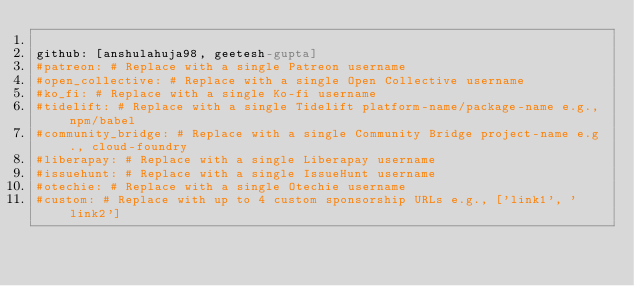<code> <loc_0><loc_0><loc_500><loc_500><_YAML_>
github: [anshulahuja98, geetesh-gupta]
#patreon: # Replace with a single Patreon username
#open_collective: # Replace with a single Open Collective username
#ko_fi: # Replace with a single Ko-fi username
#tidelift: # Replace with a single Tidelift platform-name/package-name e.g., npm/babel
#community_bridge: # Replace with a single Community Bridge project-name e.g., cloud-foundry
#liberapay: # Replace with a single Liberapay username
#issuehunt: # Replace with a single IssueHunt username
#otechie: # Replace with a single Otechie username
#custom: # Replace with up to 4 custom sponsorship URLs e.g., ['link1', 'link2']
</code> 